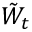Convert formula to latex. <formula><loc_0><loc_0><loc_500><loc_500>{ \tilde { W } } _ { t }</formula> 